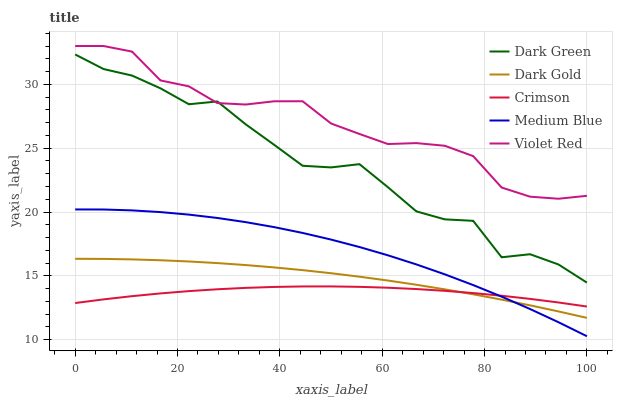Does Crimson have the minimum area under the curve?
Answer yes or no. Yes. Does Violet Red have the maximum area under the curve?
Answer yes or no. Yes. Does Dark Gold have the minimum area under the curve?
Answer yes or no. No. Does Dark Gold have the maximum area under the curve?
Answer yes or no. No. Is Dark Gold the smoothest?
Answer yes or no. Yes. Is Dark Green the roughest?
Answer yes or no. Yes. Is Violet Red the smoothest?
Answer yes or no. No. Is Violet Red the roughest?
Answer yes or no. No. Does Medium Blue have the lowest value?
Answer yes or no. Yes. Does Dark Gold have the lowest value?
Answer yes or no. No. Does Violet Red have the highest value?
Answer yes or no. Yes. Does Dark Gold have the highest value?
Answer yes or no. No. Is Medium Blue less than Violet Red?
Answer yes or no. Yes. Is Violet Red greater than Dark Gold?
Answer yes or no. Yes. Does Crimson intersect Dark Gold?
Answer yes or no. Yes. Is Crimson less than Dark Gold?
Answer yes or no. No. Is Crimson greater than Dark Gold?
Answer yes or no. No. Does Medium Blue intersect Violet Red?
Answer yes or no. No. 